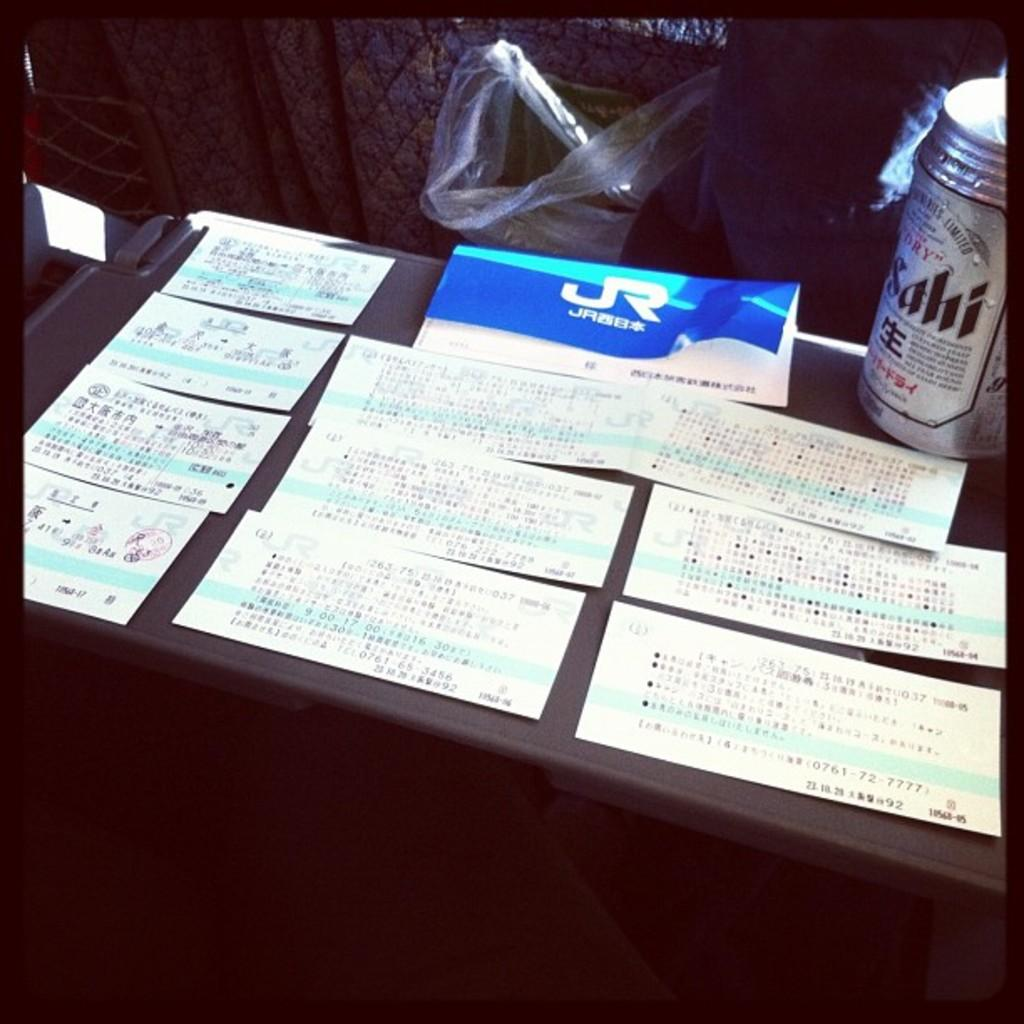<image>
Offer a succinct explanation of the picture presented. Several cards with Oriental text on them sit next to can of dry sahi. 